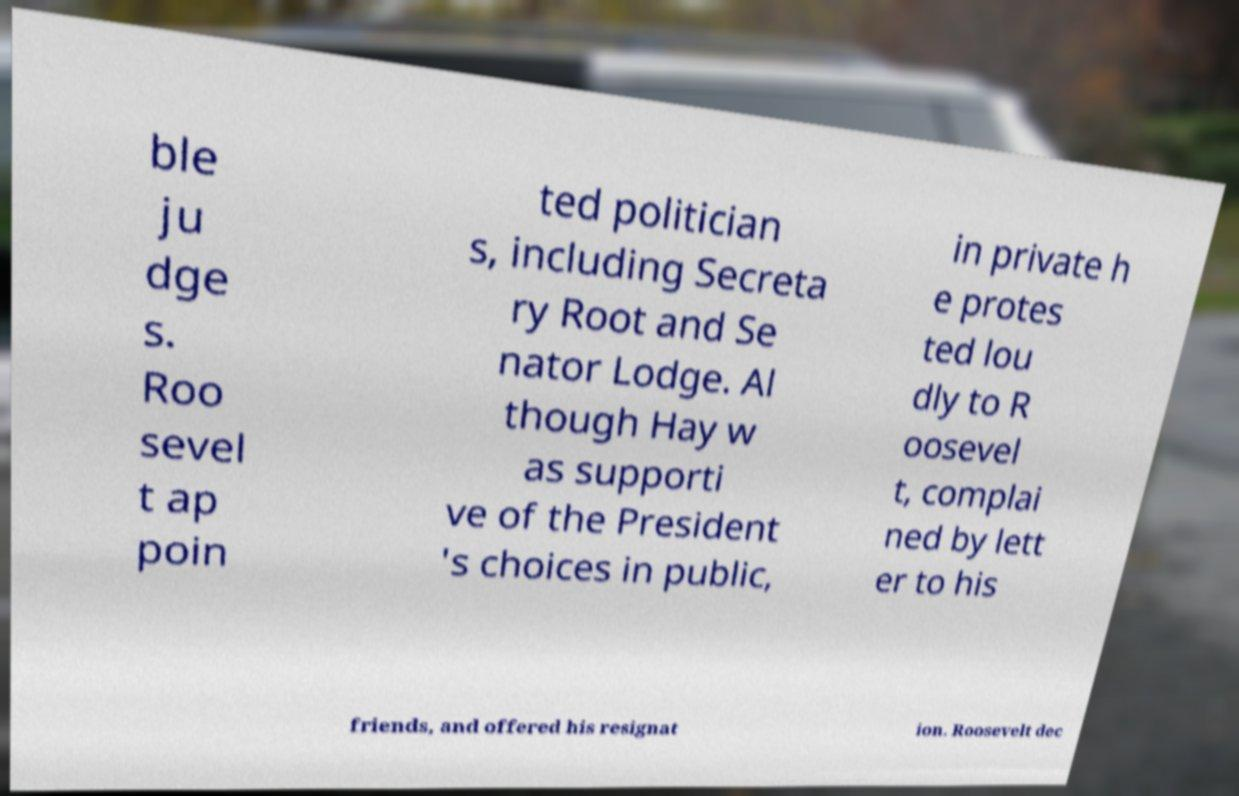Could you assist in decoding the text presented in this image and type it out clearly? ble ju dge s. Roo sevel t ap poin ted politician s, including Secreta ry Root and Se nator Lodge. Al though Hay w as supporti ve of the President 's choices in public, in private h e protes ted lou dly to R oosevel t, complai ned by lett er to his friends, and offered his resignat ion. Roosevelt dec 